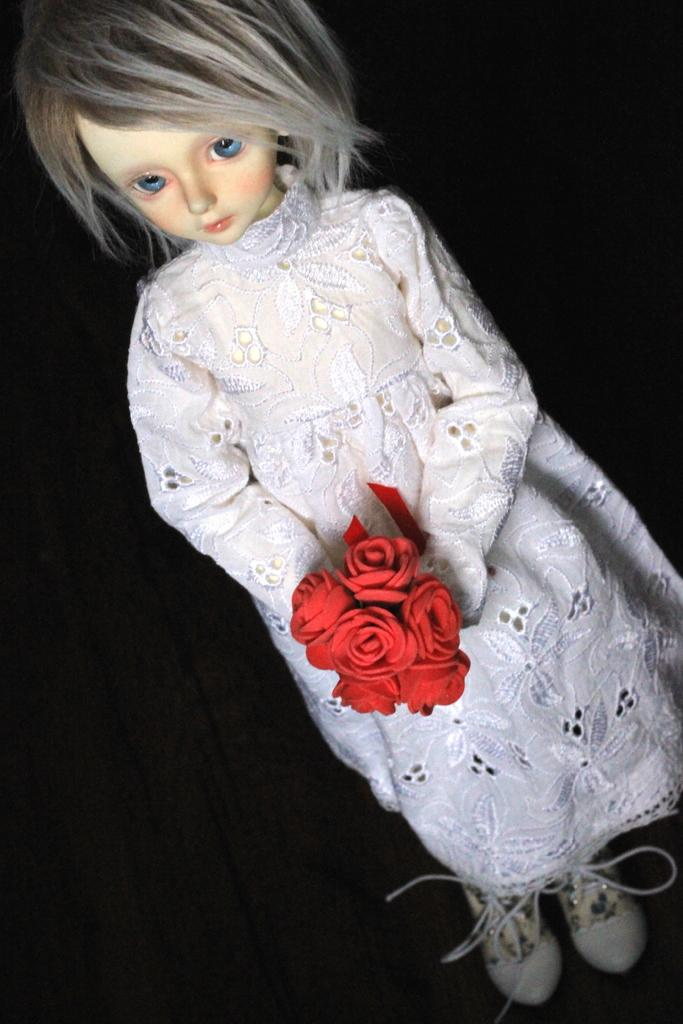What is the main subject of the image? There is a girl doll in the image. What is the girl doll wearing? The girl doll is wearing a white dress and white shoes with laces. What is the girl doll holding? The girl doll is holding red flowers. How would you describe the background of the image? The background of the image appears to be dark. What type of wine is being served on the railway in the image? There is no wine or railway present in the image; it features a girl doll wearing a white dress and holding red flowers. How far can the girl doll stretch in the image? The girl doll is not a living being and cannot stretch; it is an inanimate object. 